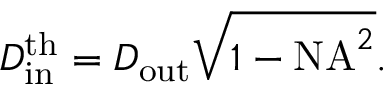<formula> <loc_0><loc_0><loc_500><loc_500>D _ { i n } ^ { t h } = D _ { o u t } \sqrt { 1 - N A ^ { 2 } } .</formula> 